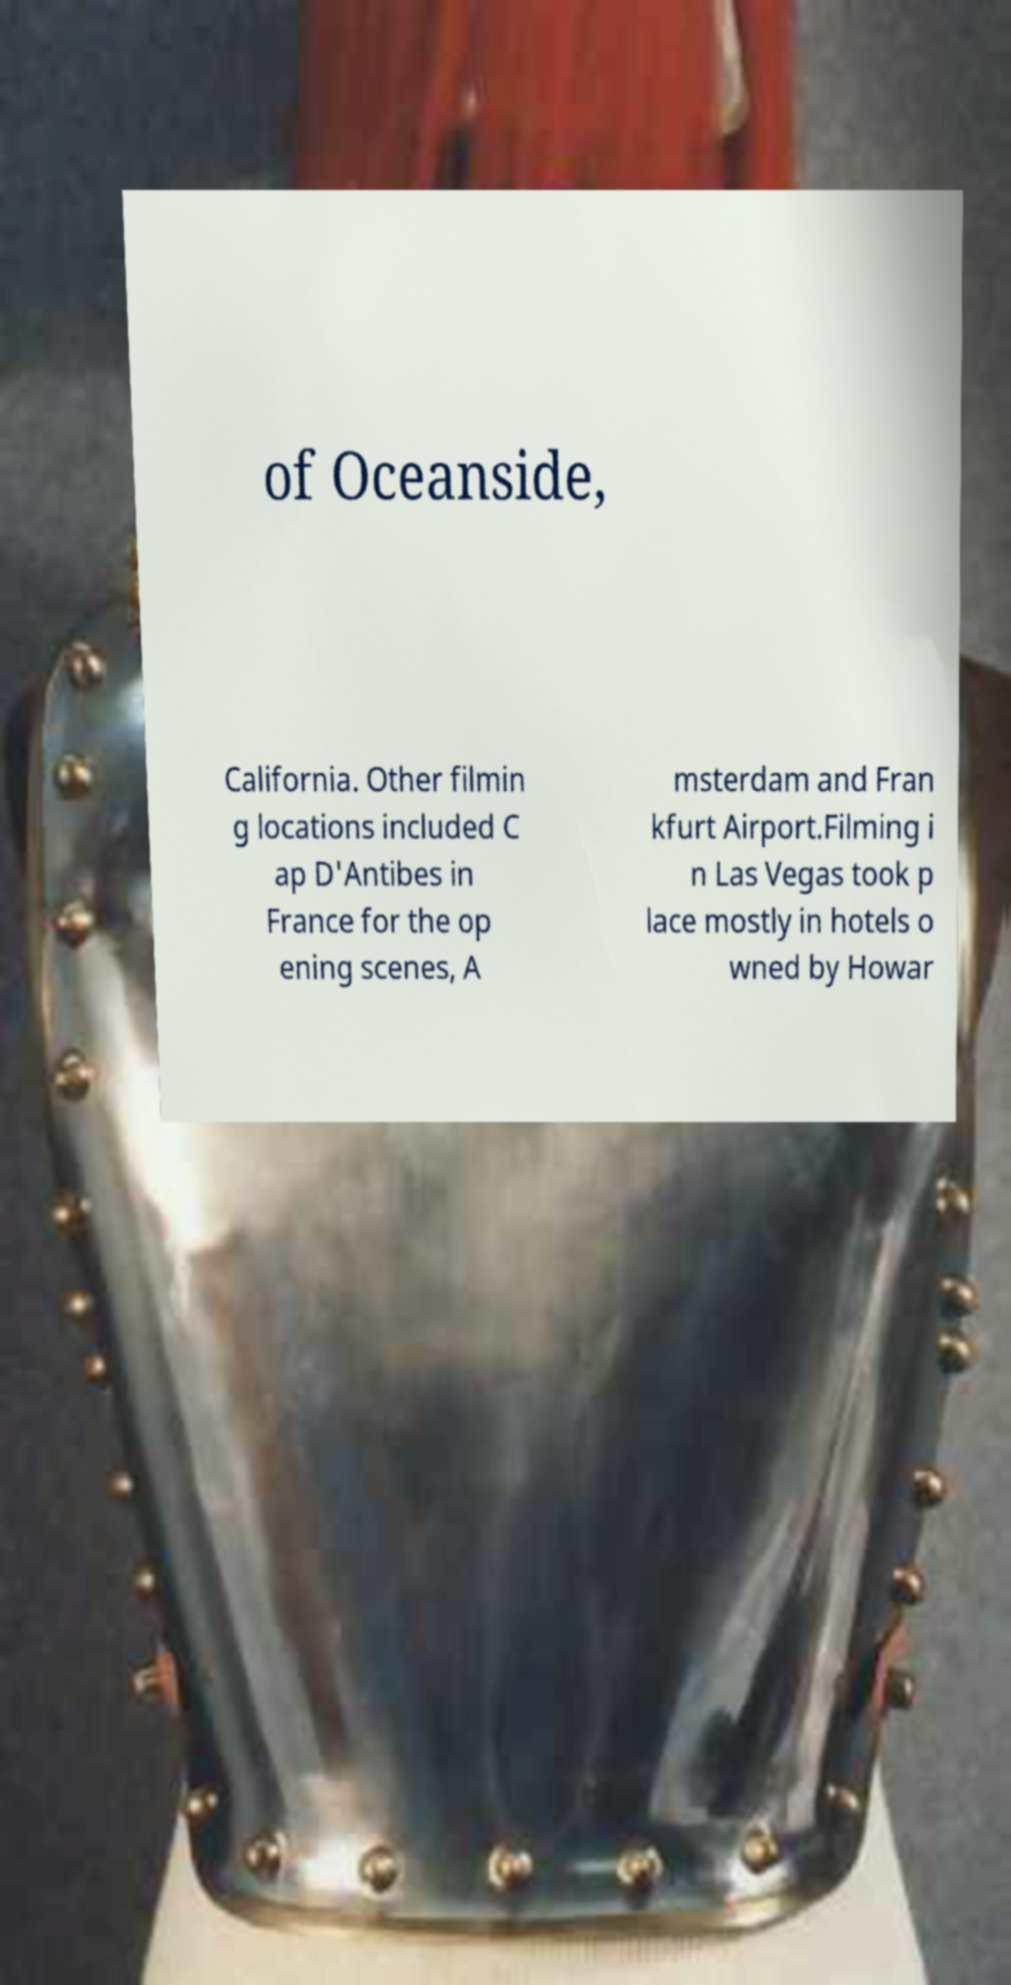For documentation purposes, I need the text within this image transcribed. Could you provide that? of Oceanside, California. Other filmin g locations included C ap D'Antibes in France for the op ening scenes, A msterdam and Fran kfurt Airport.Filming i n Las Vegas took p lace mostly in hotels o wned by Howar 